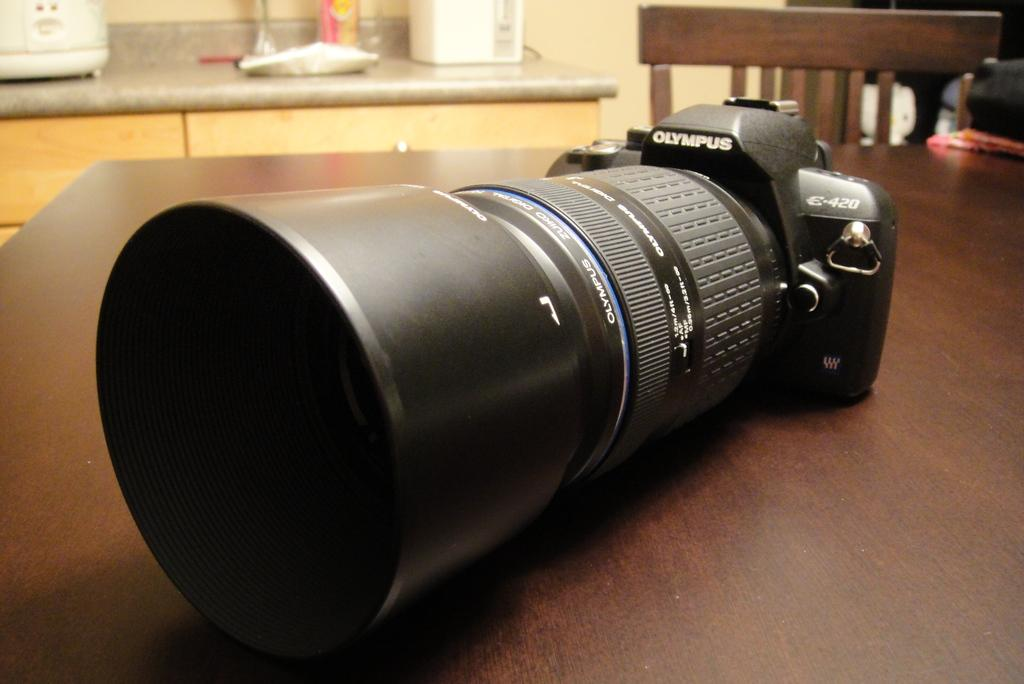What type of furniture is present in the image? There is a table and a chair in the image. What object can be found on the table? The table contains a camera. What additional feature is visible in the top left of the image? There is a counter top in the top left of the image. How many kittens are sitting on the chair in the image? There are no kittens present in the image; only a table, chair, camera, and counter top can be seen. 